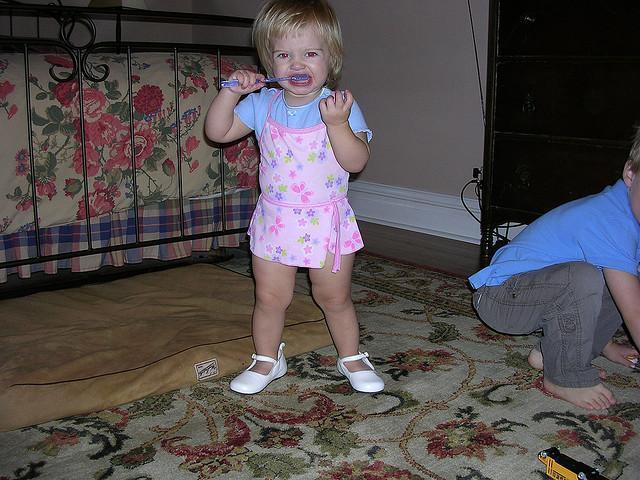How many beds are there?
Give a very brief answer. 1. How many people are in the picture?
Give a very brief answer. 2. How many cakes are there?
Give a very brief answer. 0. 